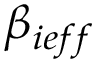Convert formula to latex. <formula><loc_0><loc_0><loc_500><loc_500>\beta _ { i e f f }</formula> 